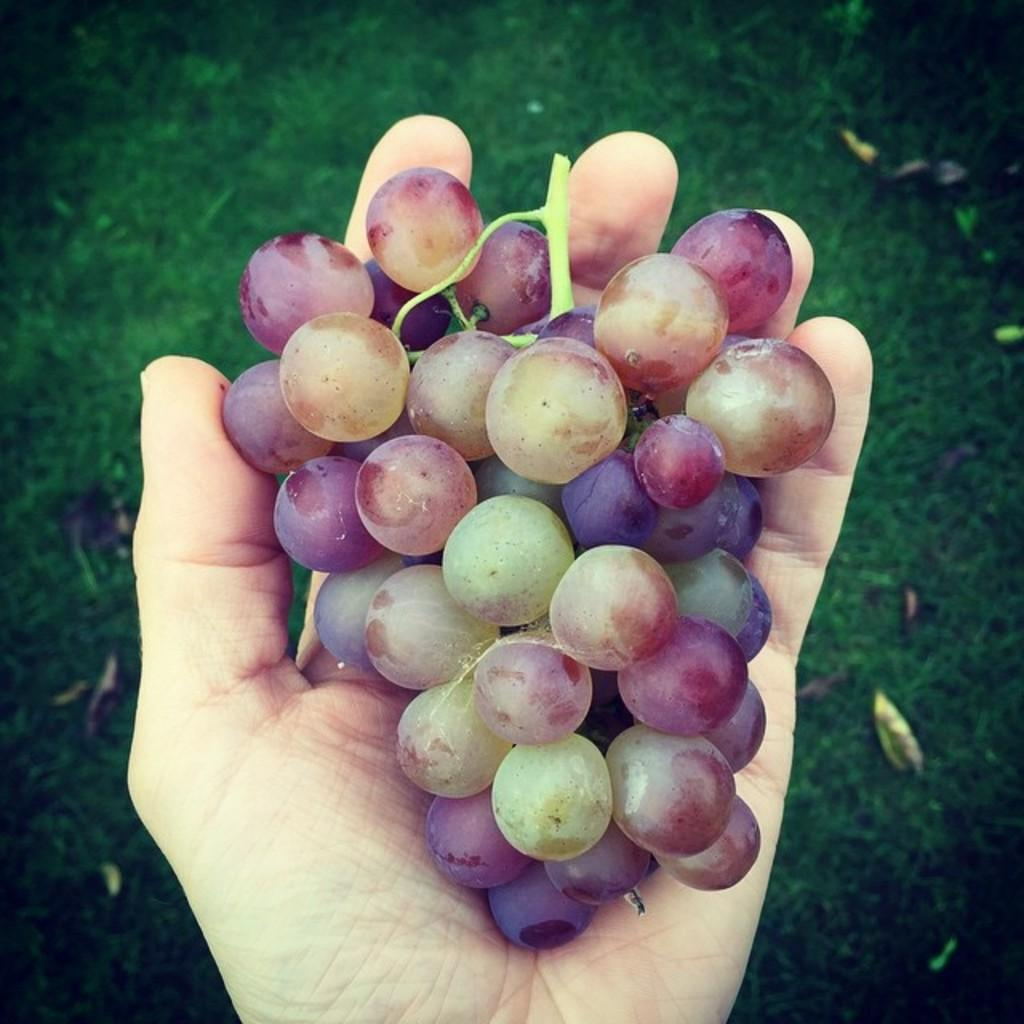What is the main subject of the image? There is a person in the image. What is the person holding in their hand? The person is holding a bunch of grapes in their hand. What type of vegetation can be seen on the ground in the image? Some leaves are visible on the grass in the image. What type of vegetable is flying above the person in the image? There is no vegetable flying above the person in the image. 